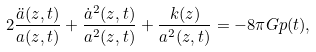<formula> <loc_0><loc_0><loc_500><loc_500>2 \frac { \ddot { a } ( z , t ) } { a ( z , t ) } + \frac { \dot { a } ^ { 2 } ( z , t ) } { a ^ { 2 } ( z , t ) } + \frac { k ( z ) } { a ^ { 2 } ( z , t ) } = - 8 \pi G p ( t ) ,</formula> 